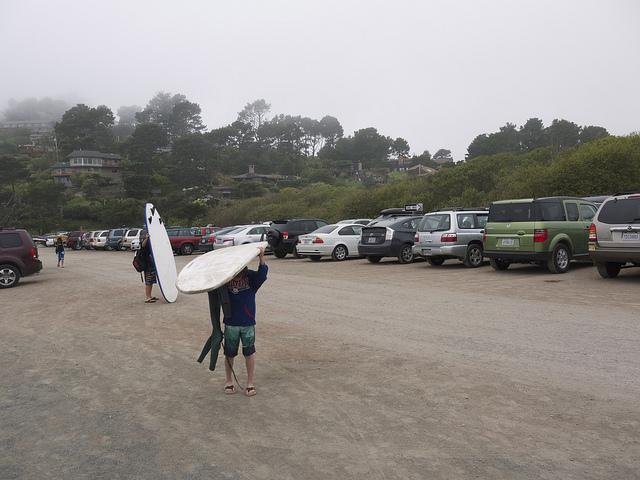Where are persons carrying the white items going? Please explain your reasoning. ocean. The people want to surf in the water. 